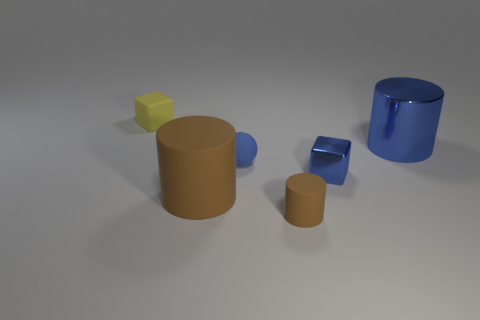There is another object that is the same shape as the yellow matte thing; what size is it?
Offer a terse response. Small. Does the tiny blue rubber object have the same shape as the large object that is in front of the big blue thing?
Provide a short and direct response. No. There is a block right of the matte cylinder right of the large brown thing; how big is it?
Offer a terse response. Small. Are there an equal number of blue metal cylinders that are in front of the ball and tiny cubes right of the small yellow matte thing?
Provide a succinct answer. No. The tiny object that is the same shape as the large brown matte object is what color?
Keep it short and to the point. Brown. What number of balls are the same color as the big metal thing?
Make the answer very short. 1. Does the tiny rubber thing that is on the left side of the large rubber thing have the same shape as the tiny shiny object?
Your answer should be compact. Yes. There is a tiny blue object that is behind the small cube that is in front of the big thing that is behind the large brown rubber cylinder; what shape is it?
Provide a succinct answer. Sphere. What is the size of the blue metal cylinder?
Your answer should be very brief. Large. What color is the tiny block that is made of the same material as the ball?
Offer a very short reply. Yellow. 